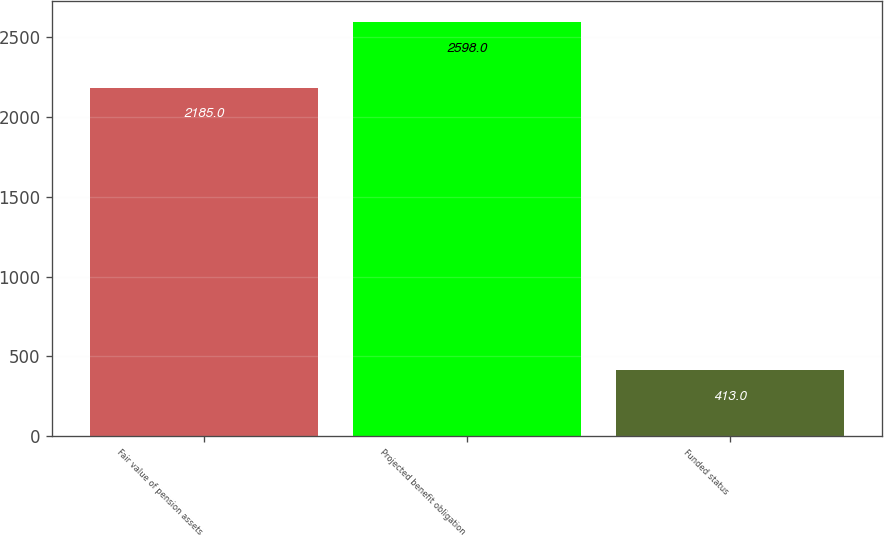Convert chart to OTSL. <chart><loc_0><loc_0><loc_500><loc_500><bar_chart><fcel>Fair value of pension assets<fcel>Projected benefit obligation<fcel>Funded status<nl><fcel>2185<fcel>2598<fcel>413<nl></chart> 